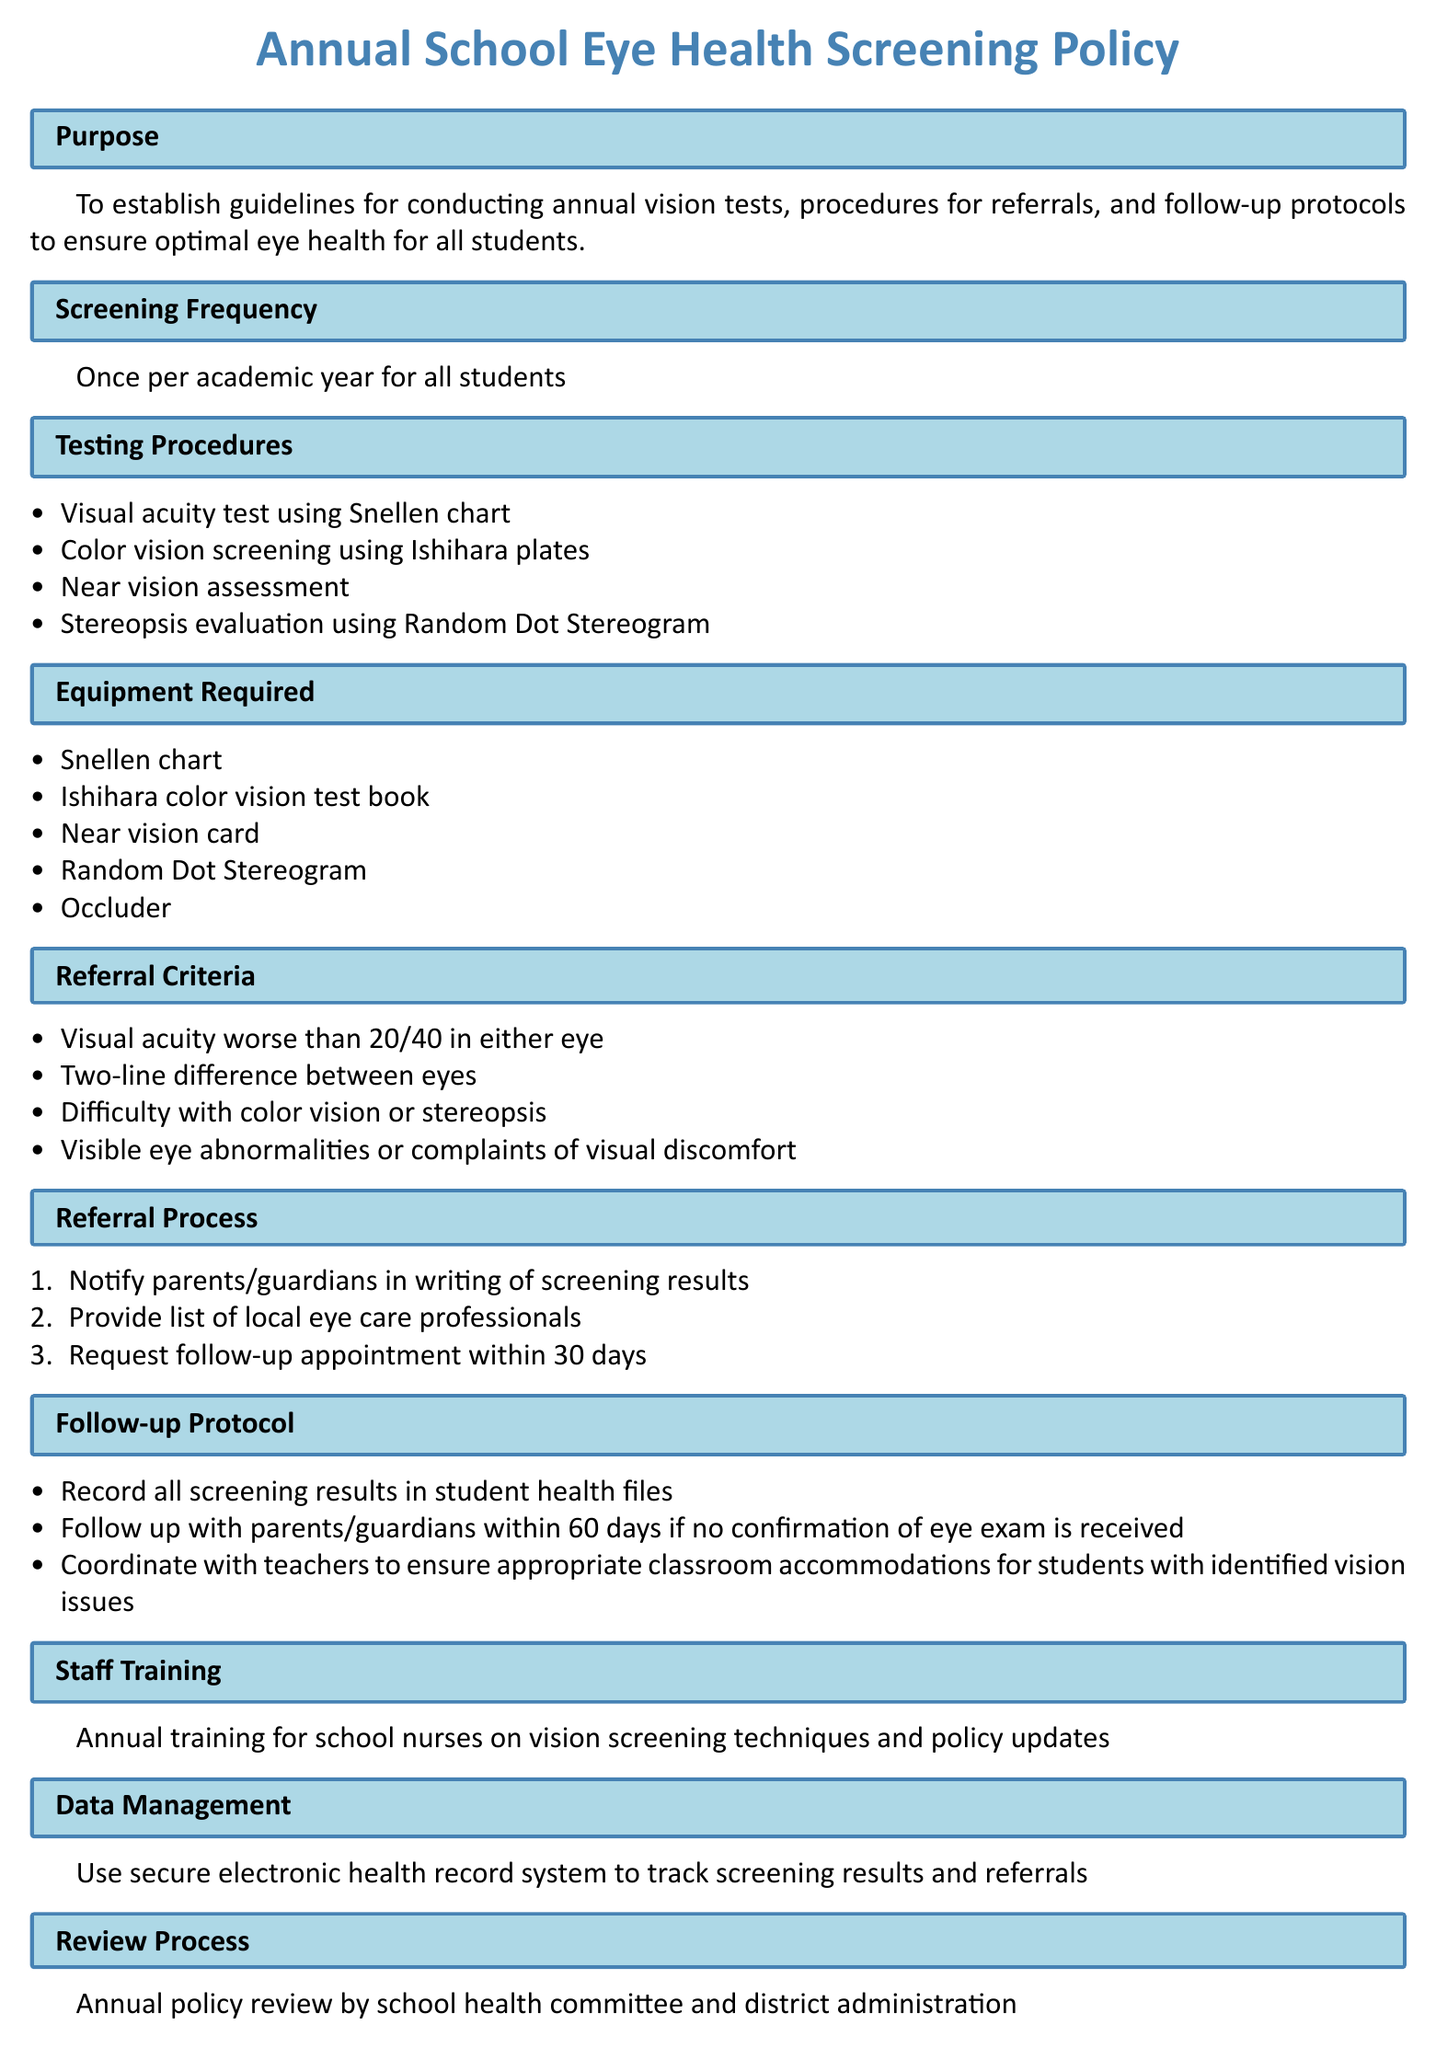What is the purpose of the policy? The policy aims to establish guidelines for conducting annual vision tests, procedures for referrals, and follow-up protocols to ensure optimal eye health for all students.
Answer: To establish guidelines for conducting annual vision tests, procedures for referrals, and follow-up protocols to ensure optimal eye health for all students How often should screenings be conducted? The document specifies that screenings should be conducted once per academic year for all students.
Answer: Once per academic year What is the maximum visual acuity allowed for a referral? The referral criteria state that visual acuity worse than 20/40 in either eye must be considered for referral.
Answer: 20/40 What equipment is required for the screening? The document lists the equipment, which includes the Snellen chart, Ishihara color vision test book, near vision card, Random Dot Stereogram, and occluder.
Answer: Snellen chart, Ishihara color vision test book, near vision card, Random Dot Stereogram, occluder What should be done if no confirmation of an eye exam is received? The follow-up protocol requires that school staff follow up with parents/guardians within 60 days if no confirmation is received.
Answer: Follow up within 60 days What type of training is mandated for school nurses? The policy mandates annual training for school nurses on vision screening techniques and policy updates.
Answer: Annual training Who is responsible for reviewing the policy? The document states that the annual policy review is conducted by the school health committee and district administration.
Answer: School health committee and district administration 